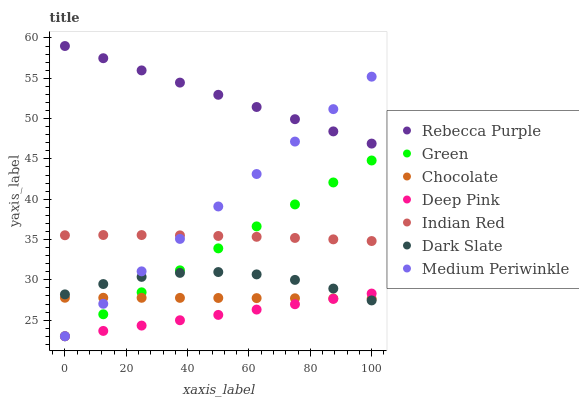Does Deep Pink have the minimum area under the curve?
Answer yes or no. Yes. Does Rebecca Purple have the maximum area under the curve?
Answer yes or no. Yes. Does Medium Periwinkle have the minimum area under the curve?
Answer yes or no. No. Does Medium Periwinkle have the maximum area under the curve?
Answer yes or no. No. Is Medium Periwinkle the smoothest?
Answer yes or no. Yes. Is Dark Slate the roughest?
Answer yes or no. Yes. Is Chocolate the smoothest?
Answer yes or no. No. Is Chocolate the roughest?
Answer yes or no. No. Does Deep Pink have the lowest value?
Answer yes or no. Yes. Does Chocolate have the lowest value?
Answer yes or no. No. Does Rebecca Purple have the highest value?
Answer yes or no. Yes. Does Medium Periwinkle have the highest value?
Answer yes or no. No. Is Deep Pink less than Rebecca Purple?
Answer yes or no. Yes. Is Rebecca Purple greater than Dark Slate?
Answer yes or no. Yes. Does Green intersect Indian Red?
Answer yes or no. Yes. Is Green less than Indian Red?
Answer yes or no. No. Is Green greater than Indian Red?
Answer yes or no. No. Does Deep Pink intersect Rebecca Purple?
Answer yes or no. No. 